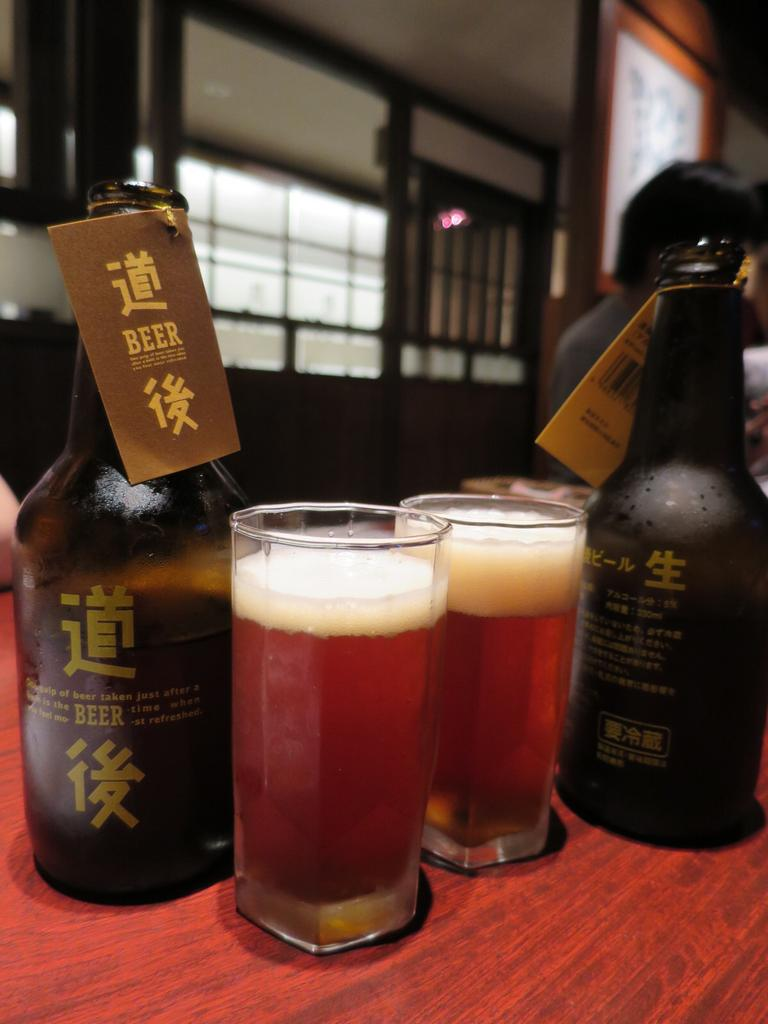What type of beverage container is present in the image? There is a beer bottle in the image. What other items related to the beverage can be seen in the image? There are beer glasses in the image. Where are the beer bottle and glasses located? The beer bottle and glasses are on a table. Can you describe the people in the background of the image? The provided facts do not give information about the people in the background, so we cannot describe them. What type of boat is visible in the image? There is no boat present in the image. What knowledge can be gained from the image about the boat? Since there is no boat in the image, no knowledge about a boat can be gained from it. 